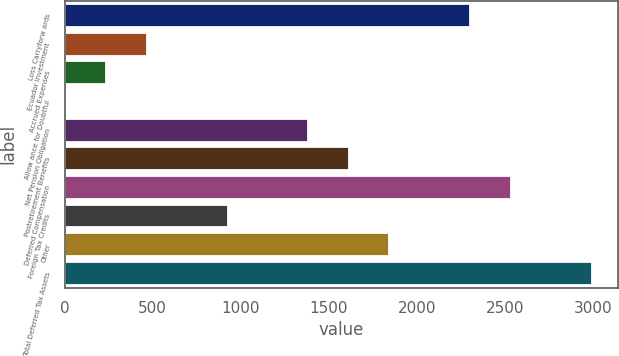Convert chart to OTSL. <chart><loc_0><loc_0><loc_500><loc_500><bar_chart><fcel>Loss Carryforw ards<fcel>Ecuador Investment<fcel>Accrued Expenses<fcel>Allow ance for Doubtful<fcel>Net Pension Obligation<fcel>Postretirement Benefits<fcel>Deferred Compensation<fcel>Foreign Tax Credits<fcel>Other<fcel>Total Deferred Tax Assets<nl><fcel>2302<fcel>465.2<fcel>235.6<fcel>6<fcel>1383.6<fcel>1613.2<fcel>2531.6<fcel>924.4<fcel>1842.8<fcel>2990.8<nl></chart> 